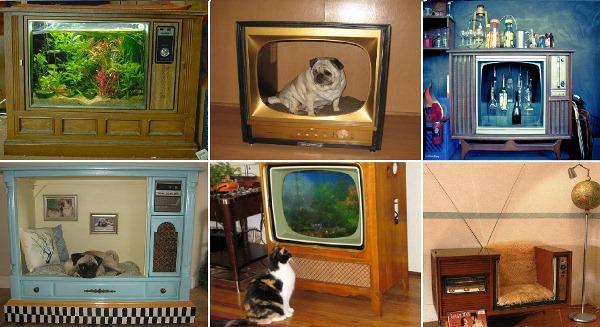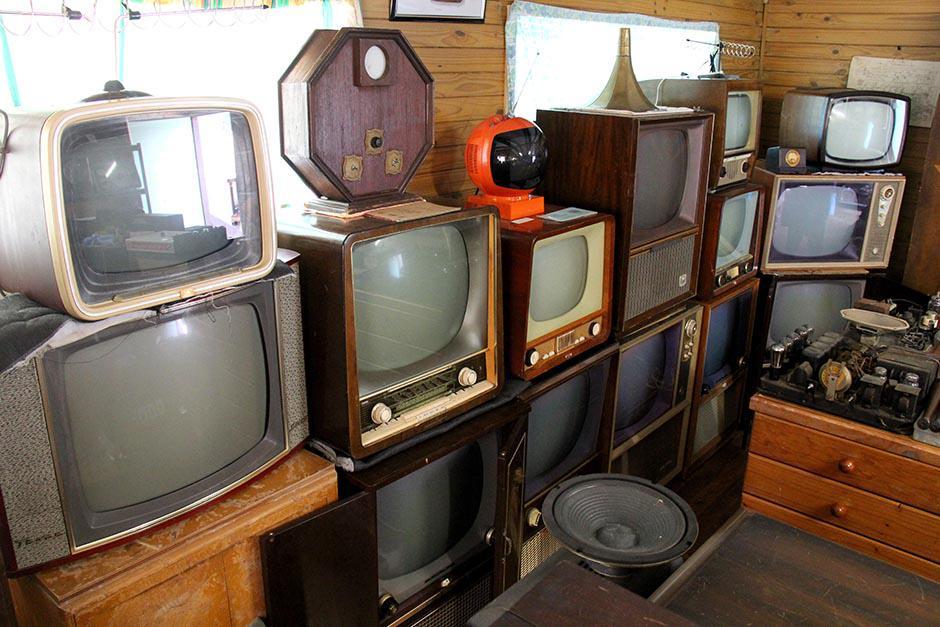The first image is the image on the left, the second image is the image on the right. Evaluate the accuracy of this statement regarding the images: "There are two tvs, and one of them has had its screen removed.". Is it true? Answer yes or no. No. The first image is the image on the left, the second image is the image on the right. For the images displayed, is the sentence "At least one animal is inside a hollowed out antique television set." factually correct? Answer yes or no. Yes. 